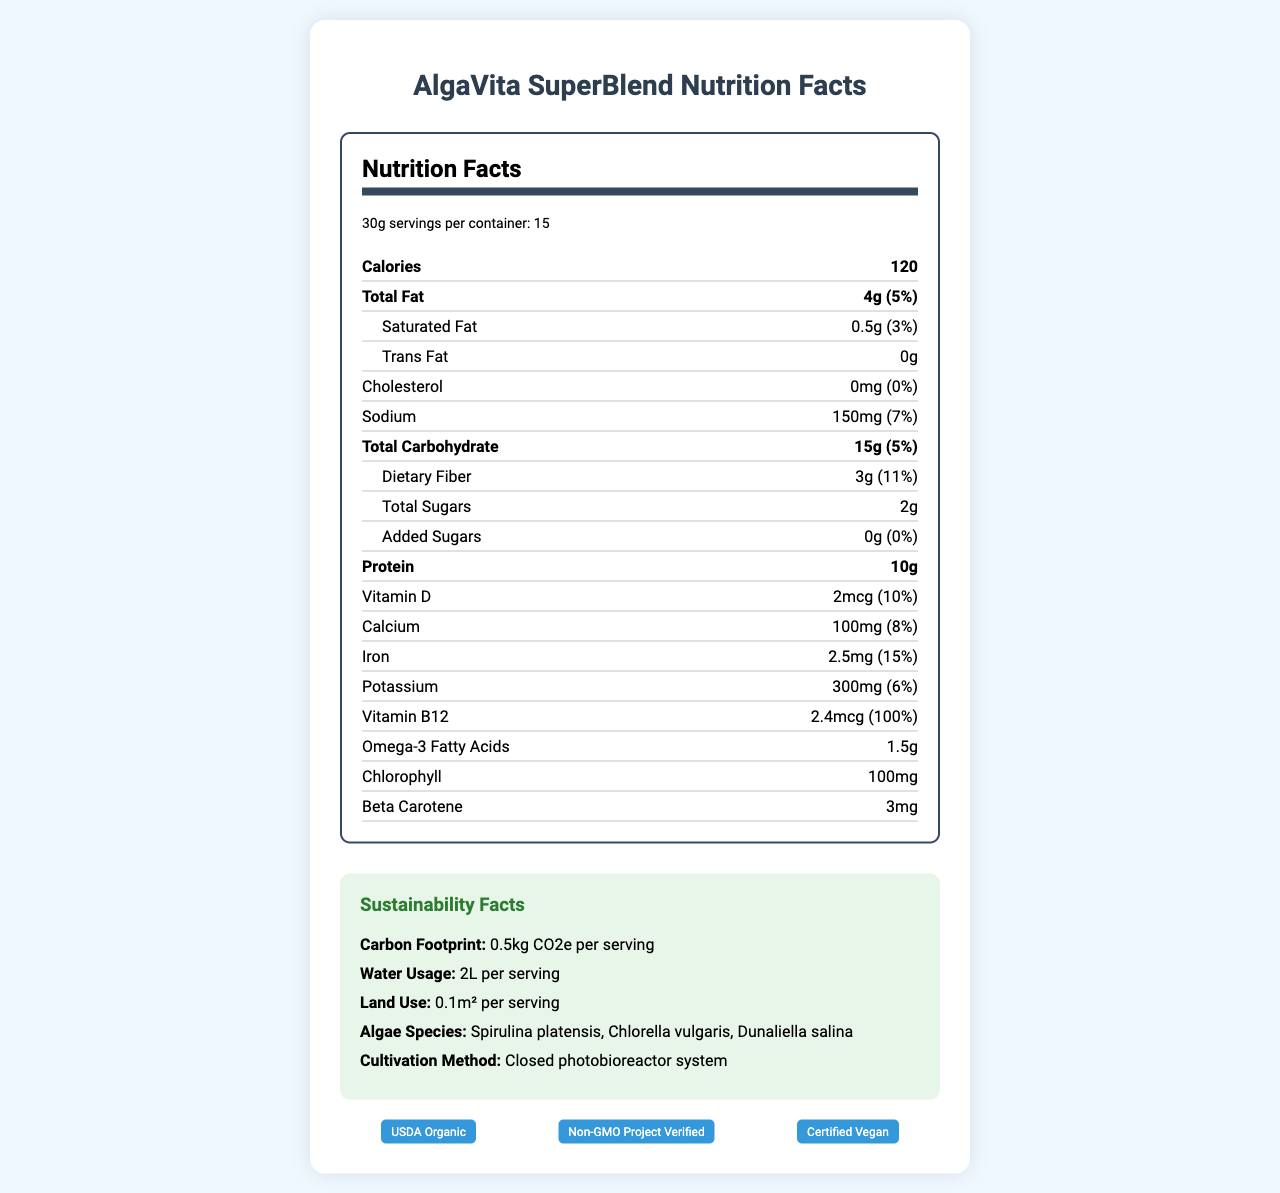what is the serving size for AlgaVita SuperBlend? The document states that the serving size for AlgaVita SuperBlend is 30g.
Answer: 30g how many servings are there per container? The document indicates that there are 15 servings per container.
Answer: 15 how much protein is in each serving? Each serving contains 10g of protein according to the nutrition facts.
Answer: 10g what is the amount and daily value percentage of dietary fiber in a serving? The document shows that each serving contains 3g of dietary fiber, which is 11% of the daily value.
Answer: 3g, 11% what is the carbon footprint per serving of AlgaVita SuperBlend? The sustainability facts section specifies that the carbon footprint is 0.5kg CO2e per serving.
Answer: 0.5kg CO2e per serving how many grams of total fat are in each serving? The nutrition facts state that each serving contains 4g of total fat.
Answer: 4g what is the daily value percentage for calcium in a serving? According to the document, the daily value percentage for calcium is 8%.
Answer: 8% which of the following algae species is included in AlgaVita SuperBlend? A. Spirulina platensis B. Ulva lactuca C. Gracilaria edulis The algae species listed in the document include Spirulina platensis, but not Ulva lactuca or Gracilaria edulis.
Answer: A how much omega-3 fatty acids are in a serving? The document specifies that there are 1.5g of omega-3 fatty acids in each serving.
Answer: 1.5g is AlgaVita SuperBlend certified vegan? One of the listed certifications for the product is "Certified Vegan".
Answer: Yes select the sustainable cultivation method used for AlgaVita SuperBlend: I. Open pond system II. Closed photobioreactor system III. Vertical farming The document states that the cultivation method used is a "Closed photobioreactor system".
Answer: II does AlgaVita SuperBlend contain any added sugars? The nutrition facts list 0g of added sugars.
Answer: No summarize the overall nutritional profile and sustainability features of AlgaVita SuperBlend. The product provides a comprehensive range of essential nutrients while maintaining strong environmental credentials due to its efficient production method and multiple certifications.
Answer: AlgaVita SuperBlend offers a high nutritional density with significant amounts of protein, dietary fiber, omega-3 fatty acids, and a range of vitamins and minerals including B12 and iron. It is sustainably produced using a closed photobioreactor system, which has a low environmental impact in terms of carbon footprint, water usage, and land use. The product is also certified USDA Organic, Non-GMO, and Vegan. what is the water usage per serving for AlgaVita SuperBlend? The sustainability facts indicate that the water usage per serving is 2L.
Answer: 2L how much cholesterol is present in each serving? The nutrition facts specify that there is 0mg of cholesterol in each serving.
Answer: 0mg which certification is NOT listed for AlgaVita SuperBlend? A. Fair Trade Certified B. USDA Organic C. Non-GMO Project Verified D. Certified Vegan The certifications listed include USDA Organic, Non-GMO Project Verified, and Certified Vegan but not Fair Trade Certified.
Answer: A can the nutritional content of this product be useful for space travel? The document includes a talking point about the potential applications of this product in space travel due to its high nutrient density.
Answer: Yes how much beta carotene is there in each serving? The document specifies that each serving of AlgaVita SuperBlend contains 3mg of beta carotene.
Answer: 3mg what is the exact amount of Vitamin D per serving? The nutrition facts state that there are 2mcg of Vitamin D per serving.
Answer: 2mcg what is the exact percentage of daily value for iron in each serving? The document indicates that each serving provides 15% of the daily value for iron.
Answer: 15% how does the environmental impact of producing AlgaVita SuperBlend compare to traditional protein sources? The document mentions that it has a low environmental impact compared to traditional protein sources, but it does not provide specific comparisons or data.
Answer: Not specifically stated 